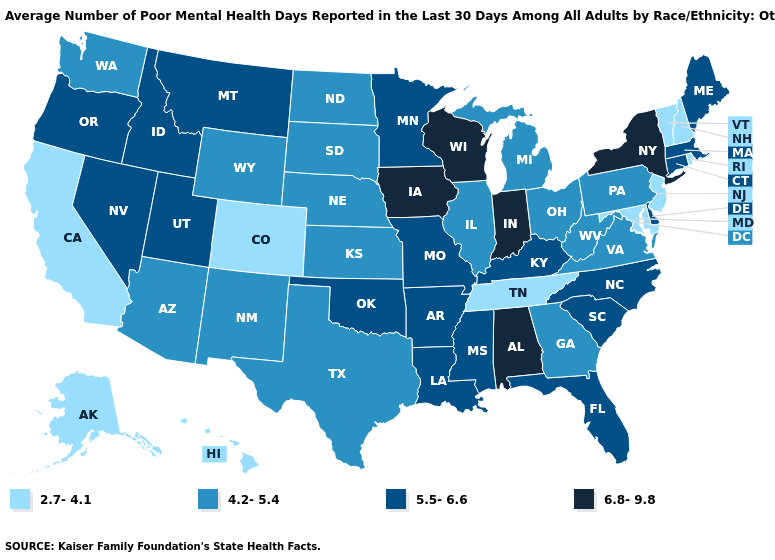Which states have the highest value in the USA?
Be succinct. Alabama, Indiana, Iowa, New York, Wisconsin. Among the states that border South Carolina , which have the lowest value?
Keep it brief. Georgia. Among the states that border Oklahoma , does Colorado have the highest value?
Keep it brief. No. Is the legend a continuous bar?
Short answer required. No. What is the value of Utah?
Quick response, please. 5.5-6.6. Name the states that have a value in the range 4.2-5.4?
Quick response, please. Arizona, Georgia, Illinois, Kansas, Michigan, Nebraska, New Mexico, North Dakota, Ohio, Pennsylvania, South Dakota, Texas, Virginia, Washington, West Virginia, Wyoming. Does Virginia have the lowest value in the USA?
Short answer required. No. Does the map have missing data?
Short answer required. No. Among the states that border New Jersey , which have the highest value?
Give a very brief answer. New York. Name the states that have a value in the range 2.7-4.1?
Short answer required. Alaska, California, Colorado, Hawaii, Maryland, New Hampshire, New Jersey, Rhode Island, Tennessee, Vermont. What is the value of Mississippi?
Answer briefly. 5.5-6.6. Name the states that have a value in the range 5.5-6.6?
Keep it brief. Arkansas, Connecticut, Delaware, Florida, Idaho, Kentucky, Louisiana, Maine, Massachusetts, Minnesota, Mississippi, Missouri, Montana, Nevada, North Carolina, Oklahoma, Oregon, South Carolina, Utah. Which states have the lowest value in the West?
Write a very short answer. Alaska, California, Colorado, Hawaii. What is the value of Colorado?
Concise answer only. 2.7-4.1. What is the lowest value in states that border Alabama?
Write a very short answer. 2.7-4.1. 